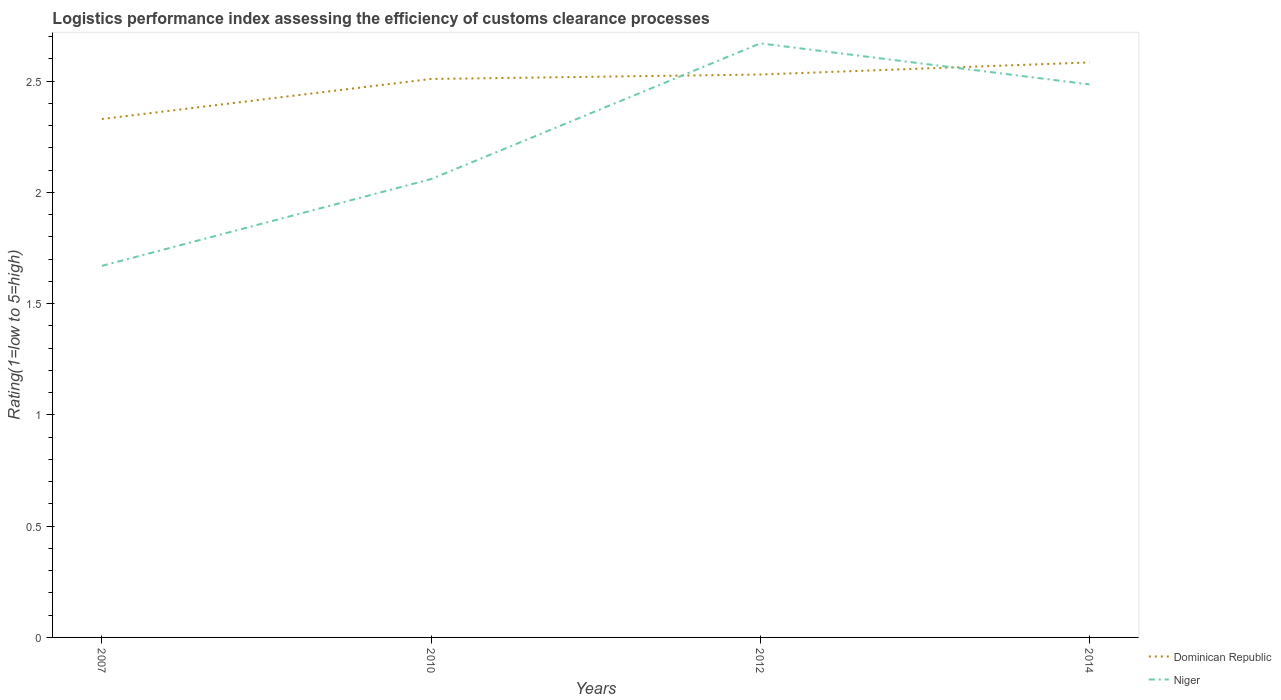Does the line corresponding to Dominican Republic intersect with the line corresponding to Niger?
Ensure brevity in your answer.  Yes. Is the number of lines equal to the number of legend labels?
Keep it short and to the point. Yes. Across all years, what is the maximum Logistic performance index in Niger?
Offer a terse response. 1.67. What is the total Logistic performance index in Niger in the graph?
Your answer should be compact. -0.39. Is the Logistic performance index in Dominican Republic strictly greater than the Logistic performance index in Niger over the years?
Ensure brevity in your answer.  No. How many lines are there?
Offer a very short reply. 2. How many years are there in the graph?
Your answer should be compact. 4. Are the values on the major ticks of Y-axis written in scientific E-notation?
Your answer should be compact. No. Does the graph contain any zero values?
Your answer should be compact. No. Does the graph contain grids?
Ensure brevity in your answer.  No. Where does the legend appear in the graph?
Provide a succinct answer. Bottom right. How are the legend labels stacked?
Provide a succinct answer. Vertical. What is the title of the graph?
Offer a very short reply. Logistics performance index assessing the efficiency of customs clearance processes. What is the label or title of the X-axis?
Your response must be concise. Years. What is the label or title of the Y-axis?
Your answer should be very brief. Rating(1=low to 5=high). What is the Rating(1=low to 5=high) in Dominican Republic in 2007?
Offer a terse response. 2.33. What is the Rating(1=low to 5=high) in Niger in 2007?
Offer a terse response. 1.67. What is the Rating(1=low to 5=high) in Dominican Republic in 2010?
Give a very brief answer. 2.51. What is the Rating(1=low to 5=high) of Niger in 2010?
Offer a terse response. 2.06. What is the Rating(1=low to 5=high) of Dominican Republic in 2012?
Your answer should be very brief. 2.53. What is the Rating(1=low to 5=high) in Niger in 2012?
Give a very brief answer. 2.67. What is the Rating(1=low to 5=high) of Dominican Republic in 2014?
Your answer should be very brief. 2.58. What is the Rating(1=low to 5=high) of Niger in 2014?
Provide a short and direct response. 2.49. Across all years, what is the maximum Rating(1=low to 5=high) of Dominican Republic?
Your response must be concise. 2.58. Across all years, what is the maximum Rating(1=low to 5=high) in Niger?
Offer a very short reply. 2.67. Across all years, what is the minimum Rating(1=low to 5=high) of Dominican Republic?
Keep it short and to the point. 2.33. Across all years, what is the minimum Rating(1=low to 5=high) in Niger?
Provide a short and direct response. 1.67. What is the total Rating(1=low to 5=high) of Dominican Republic in the graph?
Provide a short and direct response. 9.95. What is the total Rating(1=low to 5=high) in Niger in the graph?
Your answer should be very brief. 8.89. What is the difference between the Rating(1=low to 5=high) in Dominican Republic in 2007 and that in 2010?
Keep it short and to the point. -0.18. What is the difference between the Rating(1=low to 5=high) of Niger in 2007 and that in 2010?
Provide a succinct answer. -0.39. What is the difference between the Rating(1=low to 5=high) of Dominican Republic in 2007 and that in 2012?
Offer a terse response. -0.2. What is the difference between the Rating(1=low to 5=high) in Niger in 2007 and that in 2012?
Ensure brevity in your answer.  -1. What is the difference between the Rating(1=low to 5=high) of Dominican Republic in 2007 and that in 2014?
Your response must be concise. -0.25. What is the difference between the Rating(1=low to 5=high) in Niger in 2007 and that in 2014?
Give a very brief answer. -0.82. What is the difference between the Rating(1=low to 5=high) in Dominican Republic in 2010 and that in 2012?
Provide a short and direct response. -0.02. What is the difference between the Rating(1=low to 5=high) in Niger in 2010 and that in 2012?
Offer a very short reply. -0.61. What is the difference between the Rating(1=low to 5=high) of Dominican Republic in 2010 and that in 2014?
Your answer should be compact. -0.07. What is the difference between the Rating(1=low to 5=high) in Niger in 2010 and that in 2014?
Offer a terse response. -0.43. What is the difference between the Rating(1=low to 5=high) in Dominican Republic in 2012 and that in 2014?
Give a very brief answer. -0.05. What is the difference between the Rating(1=low to 5=high) of Niger in 2012 and that in 2014?
Offer a terse response. 0.18. What is the difference between the Rating(1=low to 5=high) of Dominican Republic in 2007 and the Rating(1=low to 5=high) of Niger in 2010?
Your response must be concise. 0.27. What is the difference between the Rating(1=low to 5=high) in Dominican Republic in 2007 and the Rating(1=low to 5=high) in Niger in 2012?
Give a very brief answer. -0.34. What is the difference between the Rating(1=low to 5=high) of Dominican Republic in 2007 and the Rating(1=low to 5=high) of Niger in 2014?
Offer a terse response. -0.16. What is the difference between the Rating(1=low to 5=high) in Dominican Republic in 2010 and the Rating(1=low to 5=high) in Niger in 2012?
Provide a short and direct response. -0.16. What is the difference between the Rating(1=low to 5=high) of Dominican Republic in 2010 and the Rating(1=low to 5=high) of Niger in 2014?
Provide a short and direct response. 0.02. What is the difference between the Rating(1=low to 5=high) in Dominican Republic in 2012 and the Rating(1=low to 5=high) in Niger in 2014?
Offer a very short reply. 0.04. What is the average Rating(1=low to 5=high) in Dominican Republic per year?
Offer a terse response. 2.49. What is the average Rating(1=low to 5=high) in Niger per year?
Give a very brief answer. 2.22. In the year 2007, what is the difference between the Rating(1=low to 5=high) of Dominican Republic and Rating(1=low to 5=high) of Niger?
Provide a succinct answer. 0.66. In the year 2010, what is the difference between the Rating(1=low to 5=high) in Dominican Republic and Rating(1=low to 5=high) in Niger?
Ensure brevity in your answer.  0.45. In the year 2012, what is the difference between the Rating(1=low to 5=high) in Dominican Republic and Rating(1=low to 5=high) in Niger?
Give a very brief answer. -0.14. In the year 2014, what is the difference between the Rating(1=low to 5=high) in Dominican Republic and Rating(1=low to 5=high) in Niger?
Make the answer very short. 0.1. What is the ratio of the Rating(1=low to 5=high) in Dominican Republic in 2007 to that in 2010?
Your answer should be compact. 0.93. What is the ratio of the Rating(1=low to 5=high) of Niger in 2007 to that in 2010?
Your answer should be compact. 0.81. What is the ratio of the Rating(1=low to 5=high) of Dominican Republic in 2007 to that in 2012?
Your answer should be very brief. 0.92. What is the ratio of the Rating(1=low to 5=high) in Niger in 2007 to that in 2012?
Provide a succinct answer. 0.63. What is the ratio of the Rating(1=low to 5=high) of Dominican Republic in 2007 to that in 2014?
Your response must be concise. 0.9. What is the ratio of the Rating(1=low to 5=high) of Niger in 2007 to that in 2014?
Provide a succinct answer. 0.67. What is the ratio of the Rating(1=low to 5=high) of Niger in 2010 to that in 2012?
Give a very brief answer. 0.77. What is the ratio of the Rating(1=low to 5=high) of Dominican Republic in 2010 to that in 2014?
Provide a succinct answer. 0.97. What is the ratio of the Rating(1=low to 5=high) in Niger in 2010 to that in 2014?
Offer a terse response. 0.83. What is the ratio of the Rating(1=low to 5=high) in Dominican Republic in 2012 to that in 2014?
Offer a terse response. 0.98. What is the ratio of the Rating(1=low to 5=high) in Niger in 2012 to that in 2014?
Your response must be concise. 1.07. What is the difference between the highest and the second highest Rating(1=low to 5=high) in Dominican Republic?
Give a very brief answer. 0.05. What is the difference between the highest and the second highest Rating(1=low to 5=high) of Niger?
Your answer should be very brief. 0.18. What is the difference between the highest and the lowest Rating(1=low to 5=high) in Dominican Republic?
Your answer should be very brief. 0.25. 